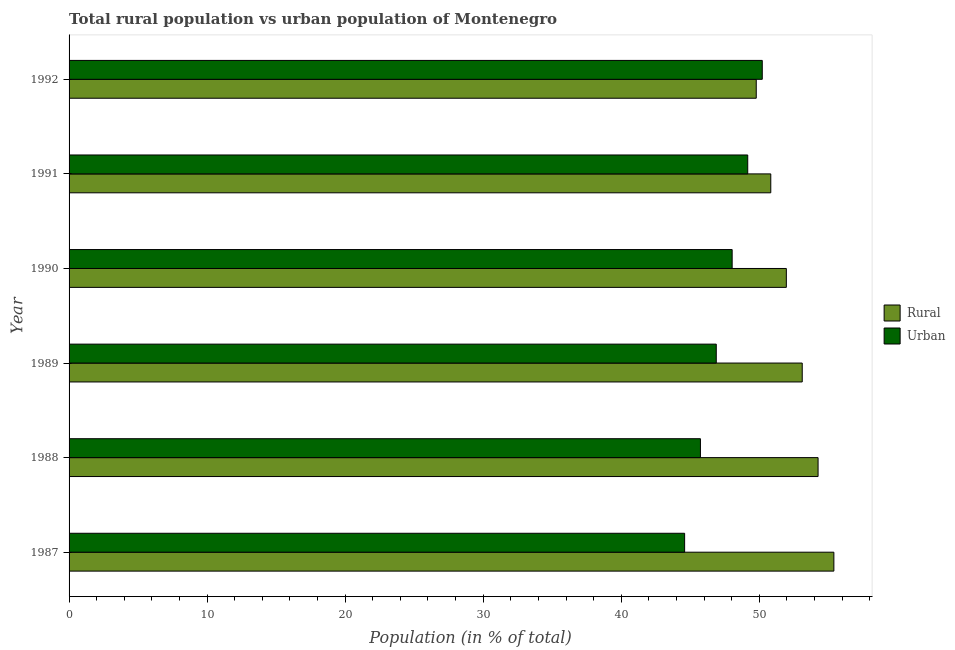How many different coloured bars are there?
Offer a terse response. 2. Are the number of bars on each tick of the Y-axis equal?
Offer a very short reply. Yes. How many bars are there on the 1st tick from the top?
Ensure brevity in your answer.  2. How many bars are there on the 6th tick from the bottom?
Offer a very short reply. 2. What is the label of the 4th group of bars from the top?
Give a very brief answer. 1989. In how many cases, is the number of bars for a given year not equal to the number of legend labels?
Provide a short and direct response. 0. What is the urban population in 1987?
Your response must be concise. 44.59. Across all years, what is the maximum urban population?
Ensure brevity in your answer.  50.22. Across all years, what is the minimum rural population?
Your answer should be very brief. 49.78. In which year was the urban population maximum?
Make the answer very short. 1992. What is the total rural population in the graph?
Make the answer very short. 315.36. What is the difference between the rural population in 1987 and that in 1988?
Your response must be concise. 1.15. What is the difference between the urban population in 1990 and the rural population in 1989?
Make the answer very short. -5.08. What is the average rural population per year?
Provide a short and direct response. 52.56. In the year 1989, what is the difference between the rural population and urban population?
Provide a short and direct response. 6.23. In how many years, is the urban population greater than 12 %?
Your answer should be very brief. 6. What is the ratio of the rural population in 1988 to that in 1990?
Keep it short and to the point. 1.04. Is the rural population in 1987 less than that in 1989?
Offer a very short reply. No. What is the difference between the highest and the second highest rural population?
Provide a short and direct response. 1.15. What is the difference between the highest and the lowest urban population?
Make the answer very short. 5.62. What does the 2nd bar from the top in 1991 represents?
Ensure brevity in your answer.  Rural. What does the 2nd bar from the bottom in 1992 represents?
Your answer should be compact. Urban. How many years are there in the graph?
Offer a terse response. 6. Does the graph contain any zero values?
Ensure brevity in your answer.  No. Does the graph contain grids?
Offer a terse response. No. What is the title of the graph?
Provide a succinct answer. Total rural population vs urban population of Montenegro. What is the label or title of the X-axis?
Give a very brief answer. Population (in % of total). What is the label or title of the Y-axis?
Provide a short and direct response. Year. What is the Population (in % of total) of Rural in 1987?
Your response must be concise. 55.41. What is the Population (in % of total) in Urban in 1987?
Offer a very short reply. 44.59. What is the Population (in % of total) in Rural in 1988?
Keep it short and to the point. 54.26. What is the Population (in % of total) of Urban in 1988?
Provide a succinct answer. 45.74. What is the Population (in % of total) in Rural in 1989?
Your answer should be very brief. 53.11. What is the Population (in % of total) of Urban in 1989?
Your answer should be very brief. 46.89. What is the Population (in % of total) of Rural in 1990?
Your response must be concise. 51.96. What is the Population (in % of total) in Urban in 1990?
Offer a very short reply. 48.04. What is the Population (in % of total) of Rural in 1991?
Make the answer very short. 50.84. What is the Population (in % of total) of Urban in 1991?
Ensure brevity in your answer.  49.16. What is the Population (in % of total) in Rural in 1992?
Offer a very short reply. 49.78. What is the Population (in % of total) of Urban in 1992?
Provide a short and direct response. 50.22. Across all years, what is the maximum Population (in % of total) in Rural?
Offer a very short reply. 55.41. Across all years, what is the maximum Population (in % of total) of Urban?
Ensure brevity in your answer.  50.22. Across all years, what is the minimum Population (in % of total) of Rural?
Provide a short and direct response. 49.78. Across all years, what is the minimum Population (in % of total) of Urban?
Your answer should be compact. 44.59. What is the total Population (in % of total) in Rural in the graph?
Give a very brief answer. 315.36. What is the total Population (in % of total) of Urban in the graph?
Provide a short and direct response. 284.64. What is the difference between the Population (in % of total) in Rural in 1987 and that in 1988?
Your answer should be compact. 1.15. What is the difference between the Population (in % of total) of Urban in 1987 and that in 1988?
Provide a short and direct response. -1.15. What is the difference between the Population (in % of total) in Rural in 1987 and that in 1989?
Make the answer very short. 2.29. What is the difference between the Population (in % of total) of Urban in 1987 and that in 1989?
Your answer should be very brief. -2.29. What is the difference between the Population (in % of total) in Rural in 1987 and that in 1990?
Provide a succinct answer. 3.44. What is the difference between the Population (in % of total) of Urban in 1987 and that in 1990?
Your response must be concise. -3.44. What is the difference between the Population (in % of total) of Rural in 1987 and that in 1991?
Keep it short and to the point. 4.57. What is the difference between the Population (in % of total) of Urban in 1987 and that in 1991?
Give a very brief answer. -4.57. What is the difference between the Population (in % of total) of Rural in 1987 and that in 1992?
Your response must be concise. 5.62. What is the difference between the Population (in % of total) in Urban in 1987 and that in 1992?
Keep it short and to the point. -5.62. What is the difference between the Population (in % of total) in Rural in 1988 and that in 1989?
Make the answer very short. 1.15. What is the difference between the Population (in % of total) in Urban in 1988 and that in 1989?
Keep it short and to the point. -1.15. What is the difference between the Population (in % of total) of Rural in 1988 and that in 1990?
Keep it short and to the point. 2.3. What is the difference between the Population (in % of total) in Urban in 1988 and that in 1990?
Ensure brevity in your answer.  -2.3. What is the difference between the Population (in % of total) of Rural in 1988 and that in 1991?
Give a very brief answer. 3.43. What is the difference between the Population (in % of total) in Urban in 1988 and that in 1991?
Give a very brief answer. -3.43. What is the difference between the Population (in % of total) of Rural in 1988 and that in 1992?
Give a very brief answer. 4.48. What is the difference between the Population (in % of total) in Urban in 1988 and that in 1992?
Your answer should be very brief. -4.48. What is the difference between the Population (in % of total) in Rural in 1989 and that in 1990?
Your response must be concise. 1.15. What is the difference between the Population (in % of total) of Urban in 1989 and that in 1990?
Offer a terse response. -1.15. What is the difference between the Population (in % of total) of Rural in 1989 and that in 1991?
Provide a short and direct response. 2.28. What is the difference between the Population (in % of total) in Urban in 1989 and that in 1991?
Your answer should be compact. -2.28. What is the difference between the Population (in % of total) of Rural in 1989 and that in 1992?
Make the answer very short. 3.33. What is the difference between the Population (in % of total) of Urban in 1989 and that in 1992?
Provide a short and direct response. -3.33. What is the difference between the Population (in % of total) in Rural in 1990 and that in 1991?
Give a very brief answer. 1.13. What is the difference between the Population (in % of total) of Urban in 1990 and that in 1991?
Offer a very short reply. -1.13. What is the difference between the Population (in % of total) in Rural in 1990 and that in 1992?
Provide a succinct answer. 2.18. What is the difference between the Population (in % of total) in Urban in 1990 and that in 1992?
Give a very brief answer. -2.18. What is the difference between the Population (in % of total) in Rural in 1991 and that in 1992?
Ensure brevity in your answer.  1.05. What is the difference between the Population (in % of total) in Urban in 1991 and that in 1992?
Ensure brevity in your answer.  -1.05. What is the difference between the Population (in % of total) in Rural in 1987 and the Population (in % of total) in Urban in 1988?
Make the answer very short. 9.67. What is the difference between the Population (in % of total) of Rural in 1987 and the Population (in % of total) of Urban in 1989?
Your answer should be very brief. 8.52. What is the difference between the Population (in % of total) in Rural in 1987 and the Population (in % of total) in Urban in 1990?
Offer a very short reply. 7.37. What is the difference between the Population (in % of total) of Rural in 1987 and the Population (in % of total) of Urban in 1991?
Your response must be concise. 6.24. What is the difference between the Population (in % of total) of Rural in 1987 and the Population (in % of total) of Urban in 1992?
Your answer should be very brief. 5.19. What is the difference between the Population (in % of total) in Rural in 1988 and the Population (in % of total) in Urban in 1989?
Make the answer very short. 7.38. What is the difference between the Population (in % of total) in Rural in 1988 and the Population (in % of total) in Urban in 1990?
Your answer should be compact. 6.22. What is the difference between the Population (in % of total) in Rural in 1988 and the Population (in % of total) in Urban in 1991?
Keep it short and to the point. 5.1. What is the difference between the Population (in % of total) in Rural in 1988 and the Population (in % of total) in Urban in 1992?
Offer a terse response. 4.04. What is the difference between the Population (in % of total) in Rural in 1989 and the Population (in % of total) in Urban in 1990?
Offer a terse response. 5.08. What is the difference between the Population (in % of total) in Rural in 1989 and the Population (in % of total) in Urban in 1991?
Give a very brief answer. 3.95. What is the difference between the Population (in % of total) in Rural in 1989 and the Population (in % of total) in Urban in 1992?
Your response must be concise. 2.9. What is the difference between the Population (in % of total) of Rural in 1990 and the Population (in % of total) of Urban in 1991?
Offer a very short reply. 2.8. What is the difference between the Population (in % of total) of Rural in 1990 and the Population (in % of total) of Urban in 1992?
Offer a very short reply. 1.75. What is the difference between the Population (in % of total) of Rural in 1991 and the Population (in % of total) of Urban in 1992?
Keep it short and to the point. 0.62. What is the average Population (in % of total) of Rural per year?
Offer a terse response. 52.56. What is the average Population (in % of total) of Urban per year?
Keep it short and to the point. 47.44. In the year 1987, what is the difference between the Population (in % of total) in Rural and Population (in % of total) in Urban?
Keep it short and to the point. 10.81. In the year 1988, what is the difference between the Population (in % of total) of Rural and Population (in % of total) of Urban?
Provide a succinct answer. 8.52. In the year 1989, what is the difference between the Population (in % of total) of Rural and Population (in % of total) of Urban?
Ensure brevity in your answer.  6.23. In the year 1990, what is the difference between the Population (in % of total) of Rural and Population (in % of total) of Urban?
Give a very brief answer. 3.93. In the year 1991, what is the difference between the Population (in % of total) in Rural and Population (in % of total) in Urban?
Give a very brief answer. 1.67. In the year 1992, what is the difference between the Population (in % of total) in Rural and Population (in % of total) in Urban?
Provide a short and direct response. -0.44. What is the ratio of the Population (in % of total) in Rural in 1987 to that in 1988?
Make the answer very short. 1.02. What is the ratio of the Population (in % of total) in Rural in 1987 to that in 1989?
Make the answer very short. 1.04. What is the ratio of the Population (in % of total) in Urban in 1987 to that in 1989?
Your answer should be very brief. 0.95. What is the ratio of the Population (in % of total) of Rural in 1987 to that in 1990?
Keep it short and to the point. 1.07. What is the ratio of the Population (in % of total) of Urban in 1987 to that in 1990?
Keep it short and to the point. 0.93. What is the ratio of the Population (in % of total) in Rural in 1987 to that in 1991?
Your answer should be very brief. 1.09. What is the ratio of the Population (in % of total) in Urban in 1987 to that in 1991?
Ensure brevity in your answer.  0.91. What is the ratio of the Population (in % of total) of Rural in 1987 to that in 1992?
Make the answer very short. 1.11. What is the ratio of the Population (in % of total) in Urban in 1987 to that in 1992?
Provide a short and direct response. 0.89. What is the ratio of the Population (in % of total) in Rural in 1988 to that in 1989?
Offer a terse response. 1.02. What is the ratio of the Population (in % of total) in Urban in 1988 to that in 1989?
Your response must be concise. 0.98. What is the ratio of the Population (in % of total) of Rural in 1988 to that in 1990?
Provide a succinct answer. 1.04. What is the ratio of the Population (in % of total) of Urban in 1988 to that in 1990?
Provide a succinct answer. 0.95. What is the ratio of the Population (in % of total) of Rural in 1988 to that in 1991?
Ensure brevity in your answer.  1.07. What is the ratio of the Population (in % of total) in Urban in 1988 to that in 1991?
Offer a terse response. 0.93. What is the ratio of the Population (in % of total) of Rural in 1988 to that in 1992?
Make the answer very short. 1.09. What is the ratio of the Population (in % of total) of Urban in 1988 to that in 1992?
Provide a succinct answer. 0.91. What is the ratio of the Population (in % of total) of Rural in 1989 to that in 1990?
Your answer should be compact. 1.02. What is the ratio of the Population (in % of total) in Urban in 1989 to that in 1990?
Provide a succinct answer. 0.98. What is the ratio of the Population (in % of total) of Rural in 1989 to that in 1991?
Your answer should be very brief. 1.04. What is the ratio of the Population (in % of total) of Urban in 1989 to that in 1991?
Your answer should be very brief. 0.95. What is the ratio of the Population (in % of total) of Rural in 1989 to that in 1992?
Make the answer very short. 1.07. What is the ratio of the Population (in % of total) in Urban in 1989 to that in 1992?
Offer a very short reply. 0.93. What is the ratio of the Population (in % of total) of Rural in 1990 to that in 1991?
Make the answer very short. 1.02. What is the ratio of the Population (in % of total) of Urban in 1990 to that in 1991?
Your response must be concise. 0.98. What is the ratio of the Population (in % of total) in Rural in 1990 to that in 1992?
Offer a very short reply. 1.04. What is the ratio of the Population (in % of total) in Urban in 1990 to that in 1992?
Your response must be concise. 0.96. What is the ratio of the Population (in % of total) of Rural in 1991 to that in 1992?
Make the answer very short. 1.02. What is the difference between the highest and the second highest Population (in % of total) of Rural?
Provide a short and direct response. 1.15. What is the difference between the highest and the second highest Population (in % of total) of Urban?
Provide a short and direct response. 1.05. What is the difference between the highest and the lowest Population (in % of total) in Rural?
Offer a terse response. 5.62. What is the difference between the highest and the lowest Population (in % of total) of Urban?
Offer a very short reply. 5.62. 